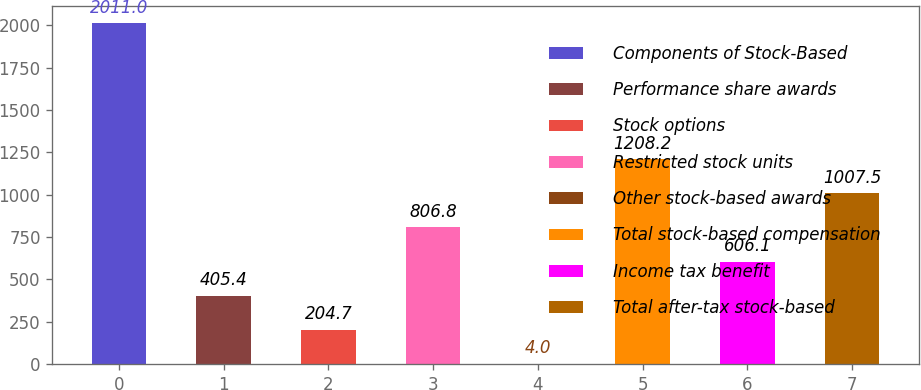<chart> <loc_0><loc_0><loc_500><loc_500><bar_chart><fcel>Components of Stock-Based<fcel>Performance share awards<fcel>Stock options<fcel>Restricted stock units<fcel>Other stock-based awards<fcel>Total stock-based compensation<fcel>Income tax benefit<fcel>Total after-tax stock-based<nl><fcel>2011<fcel>405.4<fcel>204.7<fcel>806.8<fcel>4<fcel>1208.2<fcel>606.1<fcel>1007.5<nl></chart> 